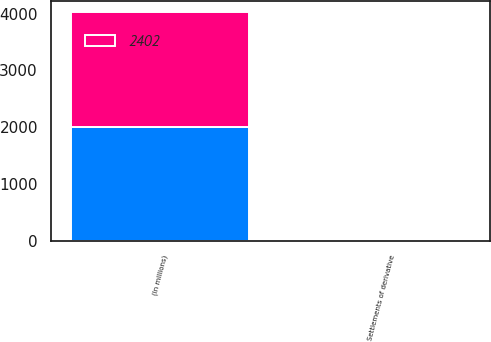<chart> <loc_0><loc_0><loc_500><loc_500><stacked_bar_chart><ecel><fcel>(In millions)<fcel>Settlements of derivative<nl><fcel>nan<fcel>2012<fcel>2<nl><fcel>2402<fcel>2010<fcel>2<nl></chart> 